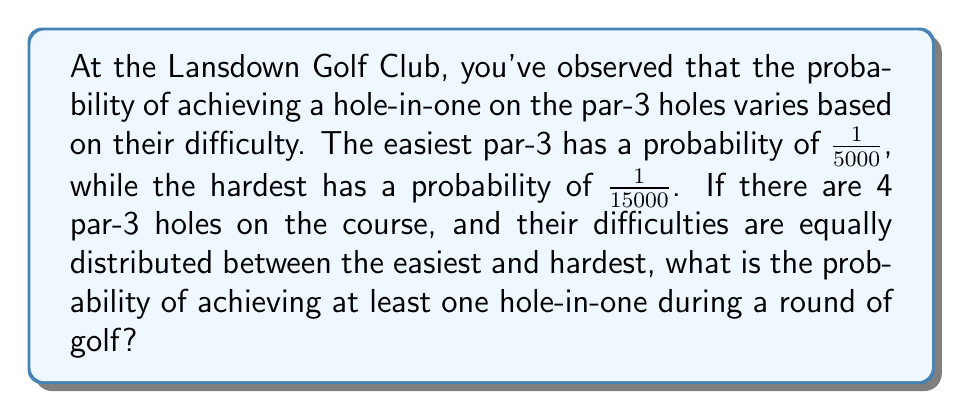Can you answer this question? Let's approach this step-by-step:

1) First, we need to determine the probabilities for each of the 4 par-3 holes. Given that they are equally distributed between 1/5000 and 1/15000, we can calculate them as follows:

   Hole 1: $p_1 = \frac{1}{5000}$
   Hole 2: $p_2 = \frac{1}{5000} + \frac{1}{3} (\frac{1}{15000} - \frac{1}{5000}) = \frac{1}{7500}$
   Hole 3: $p_3 = \frac{1}{5000} + \frac{2}{3} (\frac{1}{15000} - \frac{1}{5000}) = \frac{1}{10000}$
   Hole 4: $p_4 = \frac{1}{15000}$

2) Now, to find the probability of achieving at least one hole-in-one, it's easier to calculate the probability of not achieving any hole-in-one and then subtract this from 1.

3) The probability of not achieving a hole-in-one on a specific hole is (1 - probability of achieving a hole-in-one). So:

   Hole 1: $1 - \frac{1}{5000} = \frac{4999}{5000}$
   Hole 2: $1 - \frac{1}{7500} = \frac{7499}{7500}$
   Hole 3: $1 - \frac{1}{10000} = \frac{9999}{10000}$
   Hole 4: $1 - \frac{1}{15000} = \frac{14999}{15000}$

4) The probability of not achieving a hole-in-one on any of the holes is the product of these probabilities:

   $P(\text{no hole-in-one}) = \frac{4999}{5000} \cdot \frac{7499}{7500} \cdot \frac{9999}{10000} \cdot \frac{14999}{15000}$

5) Therefore, the probability of achieving at least one hole-in-one is:

   $P(\text{at least one hole-in-one}) = 1 - P(\text{no hole-in-one})$

   $= 1 - (\frac{4999}{5000} \cdot \frac{7499}{7500} \cdot \frac{9999}{10000} \cdot \frac{14999}{15000})$

6) Calculating this:

   $= 1 - 0.99979998$
   $= 0.00020002$

7) This can be expressed as a fraction:

   $\frac{20002}{100000000}$ or approximately $\frac{1}{4999}$
Answer: $\frac{20002}{100000000}$ or approximately $\frac{1}{4999}$ 